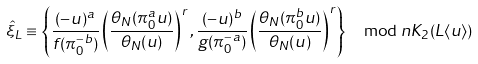Convert formula to latex. <formula><loc_0><loc_0><loc_500><loc_500>\hat { \xi } _ { L } \equiv \left \{ \frac { ( - u ) ^ { a } } { f ( \pi _ { 0 } ^ { - b } ) } \left ( \frac { \theta _ { N } ( \pi _ { 0 } ^ { a } u ) } { \theta _ { N } ( u ) } \right ) ^ { r } , \frac { ( - u ) ^ { b } } { g ( \pi _ { 0 } ^ { - a } ) } \left ( \frac { \theta _ { N } ( \pi _ { 0 } ^ { b } u ) } { \theta _ { N } ( u ) } \right ) ^ { r } \right \} \mod n K _ { 2 } ( L \langle u \rangle )</formula> 